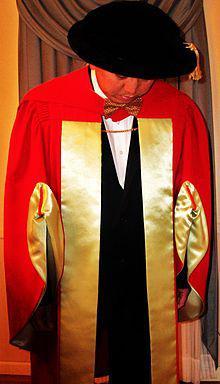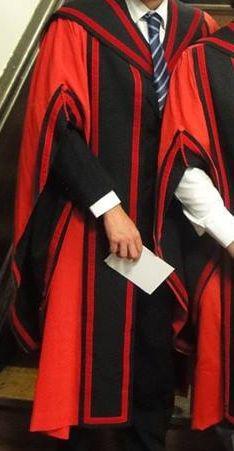The first image is the image on the left, the second image is the image on the right. For the images shown, is this caption "One of the graduates is standing at a podium." true? Answer yes or no. No. The first image is the image on the left, the second image is the image on the right. Examine the images to the left and right. Is the description "There is a man in the left image standing at a lectern." accurate? Answer yes or no. No. 